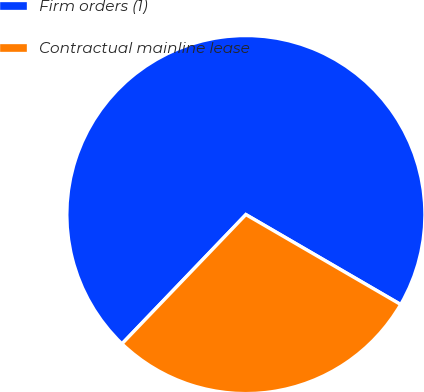Convert chart. <chart><loc_0><loc_0><loc_500><loc_500><pie_chart><fcel>Firm orders (1)<fcel>Contractual mainline lease<nl><fcel>71.21%<fcel>28.79%<nl></chart> 